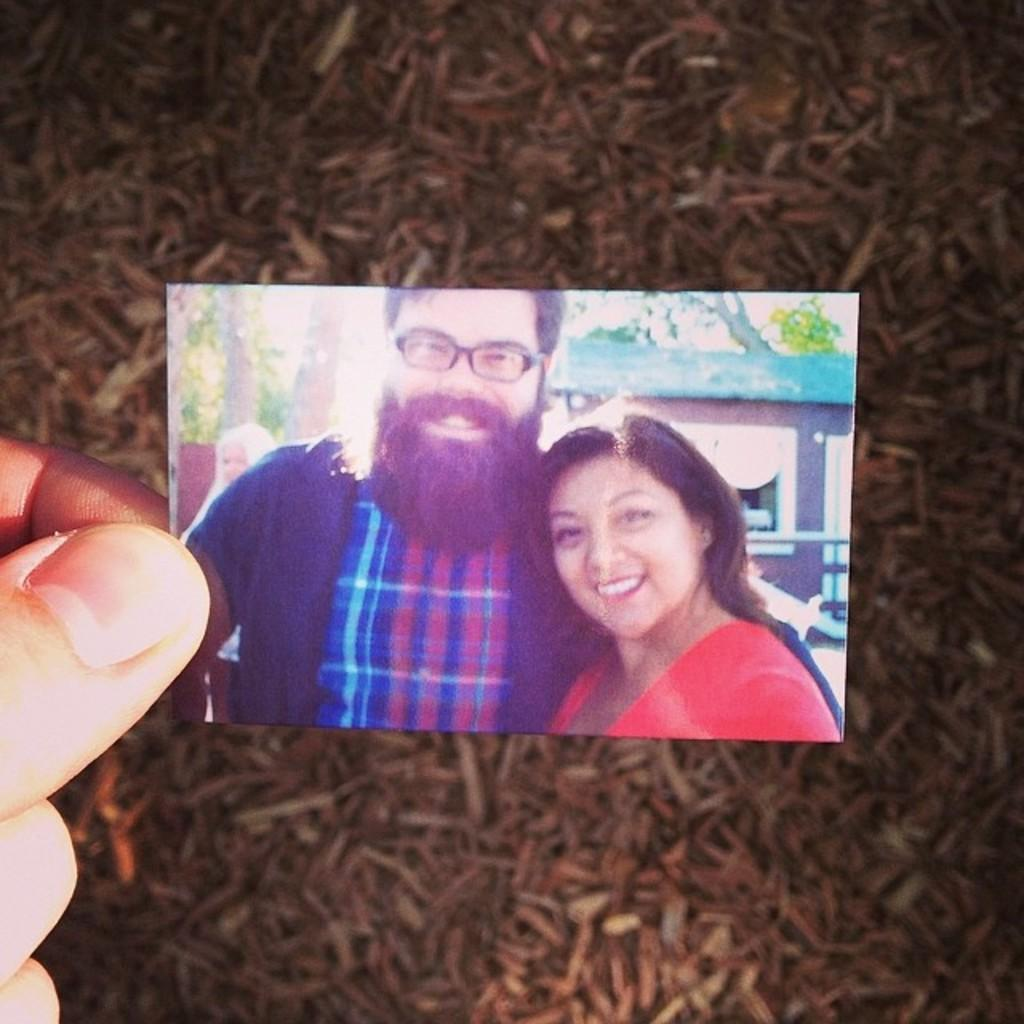What can be seen in the person's hand in the image? The person is holding a photo in their hand. What is depicted in the photo? The photo contains an image of a person and a woman. What type of alarm can be heard going off in the image? There is no alarm present in the image, and therefore no sound can be heard. 